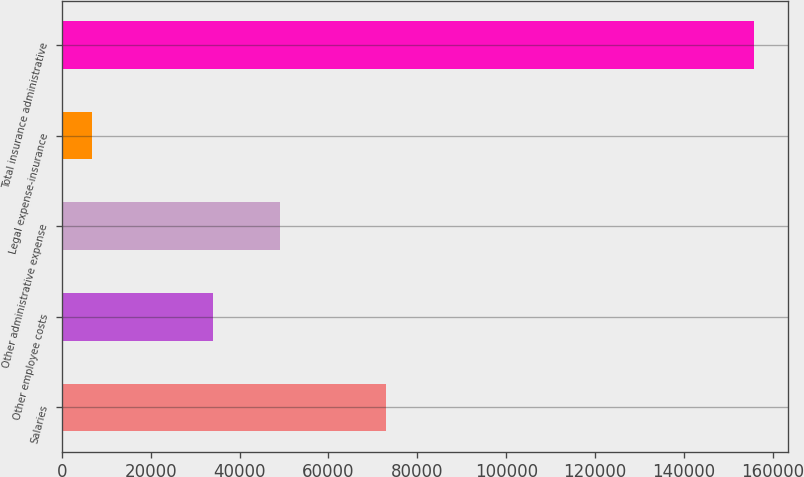Convert chart. <chart><loc_0><loc_0><loc_500><loc_500><bar_chart><fcel>Salaries<fcel>Other employee costs<fcel>Other administrative expense<fcel>Legal expense-insurance<fcel>Total insurance administrative<nl><fcel>73034<fcel>34109<fcel>48996.9<fcel>6736<fcel>155615<nl></chart> 